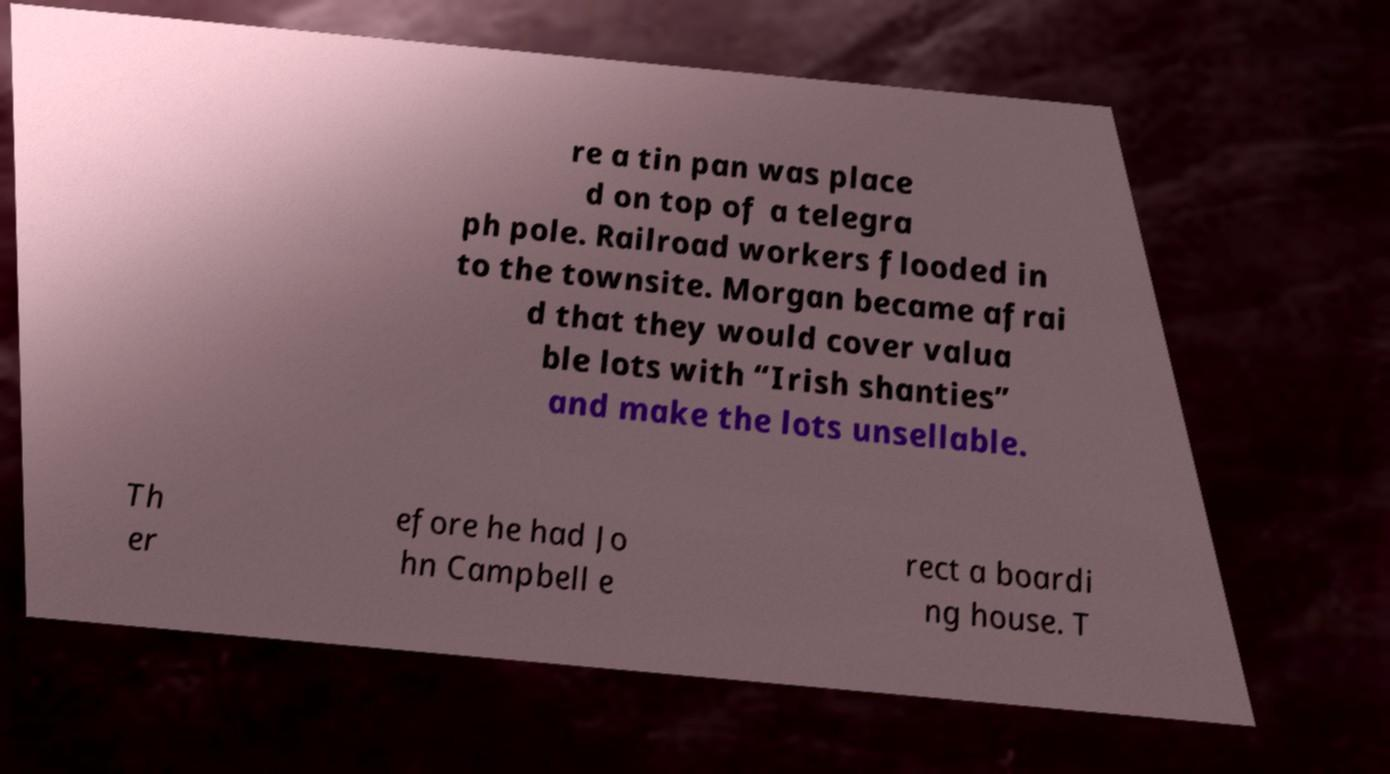There's text embedded in this image that I need extracted. Can you transcribe it verbatim? re a tin pan was place d on top of a telegra ph pole. Railroad workers flooded in to the townsite. Morgan became afrai d that they would cover valua ble lots with “Irish shanties” and make the lots unsellable. Th er efore he had Jo hn Campbell e rect a boardi ng house. T 